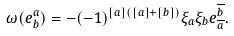Convert formula to latex. <formula><loc_0><loc_0><loc_500><loc_500>\omega ( e ^ { a } _ { b } ) = - ( - 1 ) ^ { [ a ] ( [ a ] + [ b ] ) } \xi _ { a } \xi _ { b } e ^ { \overline { b } } _ { \overline { a } } .</formula> 